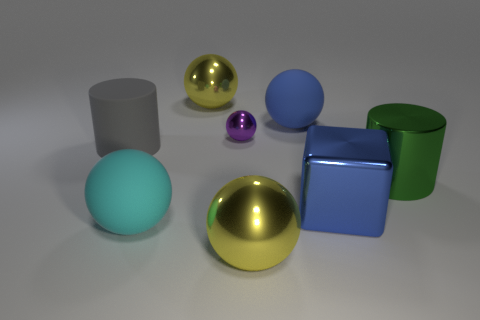What material is the big sphere that is to the left of the big yellow sphere behind the big cyan thing?
Provide a short and direct response. Rubber. What is the color of the cylinder left of the large yellow thing that is behind the large rubber thing that is in front of the cube?
Offer a very short reply. Gray. How many purple metallic things have the same size as the blue ball?
Provide a short and direct response. 0. Are there more large blue balls behind the small shiny thing than big gray matte things that are in front of the cyan matte sphere?
Give a very brief answer. Yes. The rubber sphere that is on the left side of the yellow metal thing that is in front of the big metal block is what color?
Offer a very short reply. Cyan. Do the gray cylinder and the large green thing have the same material?
Your answer should be compact. No. Are there any other things of the same shape as the green object?
Your answer should be very brief. Yes. There is a big rubber thing that is behind the big gray rubber object; does it have the same color as the shiny block?
Make the answer very short. Yes. There is a yellow object in front of the big green metal thing; is its size the same as the cylinder that is behind the big green shiny object?
Your answer should be compact. Yes. There is a blue thing that is the same material as the small purple sphere; what size is it?
Your answer should be very brief. Large. 